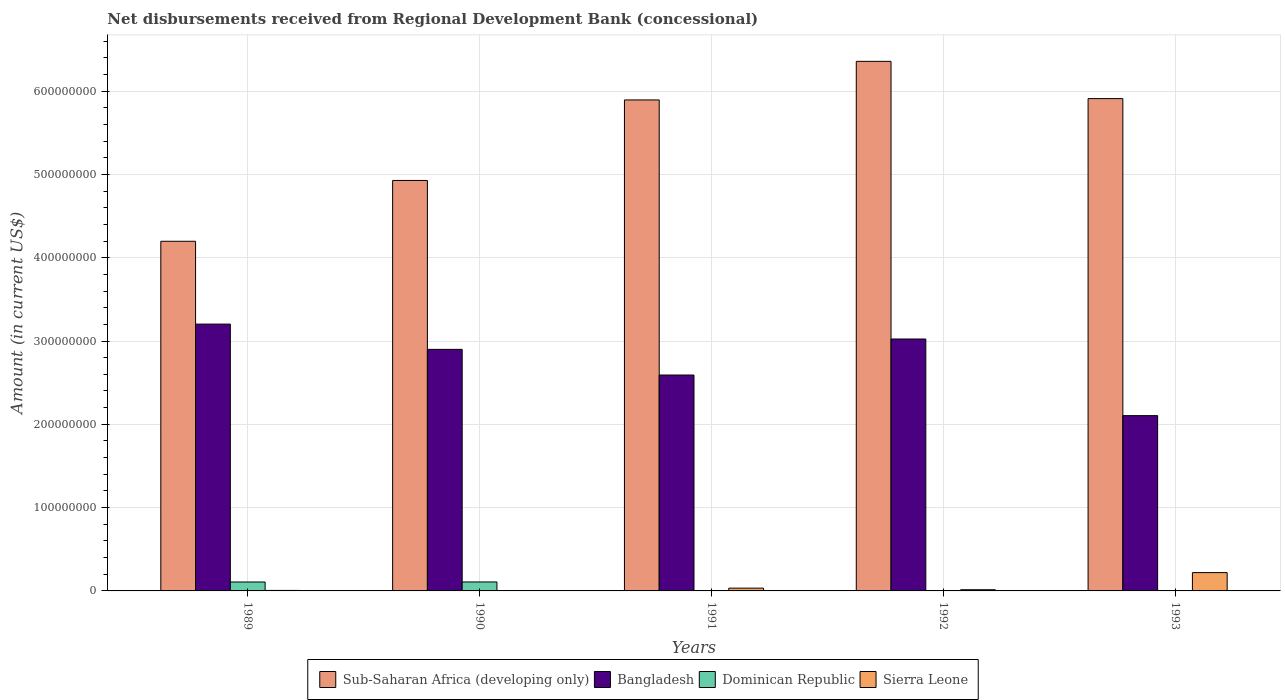How many groups of bars are there?
Keep it short and to the point. 5. Are the number of bars per tick equal to the number of legend labels?
Offer a very short reply. No. Are the number of bars on each tick of the X-axis equal?
Your answer should be very brief. No. How many bars are there on the 5th tick from the left?
Keep it short and to the point. 3. How many bars are there on the 4th tick from the right?
Provide a succinct answer. 3. What is the label of the 2nd group of bars from the left?
Provide a short and direct response. 1990. What is the amount of disbursements received from Regional Development Bank in Sierra Leone in 1991?
Your answer should be compact. 3.33e+06. Across all years, what is the maximum amount of disbursements received from Regional Development Bank in Bangladesh?
Give a very brief answer. 3.20e+08. Across all years, what is the minimum amount of disbursements received from Regional Development Bank in Sub-Saharan Africa (developing only)?
Offer a very short reply. 4.20e+08. In which year was the amount of disbursements received from Regional Development Bank in Dominican Republic maximum?
Keep it short and to the point. 1990. What is the total amount of disbursements received from Regional Development Bank in Sierra Leone in the graph?
Give a very brief answer. 2.73e+07. What is the difference between the amount of disbursements received from Regional Development Bank in Sub-Saharan Africa (developing only) in 1989 and that in 1992?
Your answer should be compact. -2.16e+08. What is the difference between the amount of disbursements received from Regional Development Bank in Dominican Republic in 1992 and the amount of disbursements received from Regional Development Bank in Bangladesh in 1991?
Your answer should be compact. -2.59e+08. What is the average amount of disbursements received from Regional Development Bank in Sierra Leone per year?
Keep it short and to the point. 5.47e+06. In the year 1992, what is the difference between the amount of disbursements received from Regional Development Bank in Bangladesh and amount of disbursements received from Regional Development Bank in Sierra Leone?
Ensure brevity in your answer.  3.01e+08. In how many years, is the amount of disbursements received from Regional Development Bank in Dominican Republic greater than 140000000 US$?
Keep it short and to the point. 0. What is the ratio of the amount of disbursements received from Regional Development Bank in Sierra Leone in 1991 to that in 1992?
Offer a terse response. 2.33. Is the difference between the amount of disbursements received from Regional Development Bank in Bangladesh in 1989 and 1992 greater than the difference between the amount of disbursements received from Regional Development Bank in Sierra Leone in 1989 and 1992?
Provide a short and direct response. Yes. What is the difference between the highest and the second highest amount of disbursements received from Regional Development Bank in Sub-Saharan Africa (developing only)?
Offer a terse response. 4.47e+07. What is the difference between the highest and the lowest amount of disbursements received from Regional Development Bank in Sierra Leone?
Offer a terse response. 2.20e+07. Is it the case that in every year, the sum of the amount of disbursements received from Regional Development Bank in Sierra Leone and amount of disbursements received from Regional Development Bank in Sub-Saharan Africa (developing only) is greater than the sum of amount of disbursements received from Regional Development Bank in Dominican Republic and amount of disbursements received from Regional Development Bank in Bangladesh?
Offer a very short reply. Yes. Are all the bars in the graph horizontal?
Offer a very short reply. No. What is the difference between two consecutive major ticks on the Y-axis?
Ensure brevity in your answer.  1.00e+08. Are the values on the major ticks of Y-axis written in scientific E-notation?
Your response must be concise. No. Does the graph contain any zero values?
Keep it short and to the point. Yes. Does the graph contain grids?
Offer a very short reply. Yes. How many legend labels are there?
Provide a succinct answer. 4. How are the legend labels stacked?
Give a very brief answer. Horizontal. What is the title of the graph?
Make the answer very short. Net disbursements received from Regional Development Bank (concessional). What is the Amount (in current US$) in Sub-Saharan Africa (developing only) in 1989?
Provide a short and direct response. 4.20e+08. What is the Amount (in current US$) of Bangladesh in 1989?
Keep it short and to the point. 3.20e+08. What is the Amount (in current US$) of Dominican Republic in 1989?
Offer a terse response. 1.07e+07. What is the Amount (in current US$) of Sierra Leone in 1989?
Your answer should be very brief. 6.03e+05. What is the Amount (in current US$) in Sub-Saharan Africa (developing only) in 1990?
Your response must be concise. 4.93e+08. What is the Amount (in current US$) of Bangladesh in 1990?
Make the answer very short. 2.90e+08. What is the Amount (in current US$) of Dominican Republic in 1990?
Provide a succinct answer. 1.08e+07. What is the Amount (in current US$) of Sub-Saharan Africa (developing only) in 1991?
Your response must be concise. 5.89e+08. What is the Amount (in current US$) of Bangladesh in 1991?
Ensure brevity in your answer.  2.59e+08. What is the Amount (in current US$) in Sierra Leone in 1991?
Your response must be concise. 3.33e+06. What is the Amount (in current US$) in Sub-Saharan Africa (developing only) in 1992?
Make the answer very short. 6.36e+08. What is the Amount (in current US$) in Bangladesh in 1992?
Make the answer very short. 3.02e+08. What is the Amount (in current US$) in Dominican Republic in 1992?
Give a very brief answer. 0. What is the Amount (in current US$) of Sierra Leone in 1992?
Provide a short and direct response. 1.43e+06. What is the Amount (in current US$) of Sub-Saharan Africa (developing only) in 1993?
Ensure brevity in your answer.  5.91e+08. What is the Amount (in current US$) of Bangladesh in 1993?
Your answer should be compact. 2.10e+08. What is the Amount (in current US$) in Sierra Leone in 1993?
Ensure brevity in your answer.  2.20e+07. Across all years, what is the maximum Amount (in current US$) in Sub-Saharan Africa (developing only)?
Provide a short and direct response. 6.36e+08. Across all years, what is the maximum Amount (in current US$) of Bangladesh?
Provide a succinct answer. 3.20e+08. Across all years, what is the maximum Amount (in current US$) in Dominican Republic?
Your answer should be compact. 1.08e+07. Across all years, what is the maximum Amount (in current US$) of Sierra Leone?
Provide a succinct answer. 2.20e+07. Across all years, what is the minimum Amount (in current US$) in Sub-Saharan Africa (developing only)?
Keep it short and to the point. 4.20e+08. Across all years, what is the minimum Amount (in current US$) of Bangladesh?
Give a very brief answer. 2.10e+08. Across all years, what is the minimum Amount (in current US$) in Dominican Republic?
Your answer should be very brief. 0. What is the total Amount (in current US$) of Sub-Saharan Africa (developing only) in the graph?
Ensure brevity in your answer.  2.73e+09. What is the total Amount (in current US$) of Bangladesh in the graph?
Keep it short and to the point. 1.38e+09. What is the total Amount (in current US$) of Dominican Republic in the graph?
Keep it short and to the point. 2.15e+07. What is the total Amount (in current US$) in Sierra Leone in the graph?
Offer a terse response. 2.73e+07. What is the difference between the Amount (in current US$) in Sub-Saharan Africa (developing only) in 1989 and that in 1990?
Give a very brief answer. -7.30e+07. What is the difference between the Amount (in current US$) in Bangladesh in 1989 and that in 1990?
Your answer should be compact. 3.03e+07. What is the difference between the Amount (in current US$) of Dominican Republic in 1989 and that in 1990?
Your answer should be very brief. -3.80e+04. What is the difference between the Amount (in current US$) in Sub-Saharan Africa (developing only) in 1989 and that in 1991?
Give a very brief answer. -1.70e+08. What is the difference between the Amount (in current US$) in Bangladesh in 1989 and that in 1991?
Give a very brief answer. 6.11e+07. What is the difference between the Amount (in current US$) of Sierra Leone in 1989 and that in 1991?
Your answer should be compact. -2.73e+06. What is the difference between the Amount (in current US$) of Sub-Saharan Africa (developing only) in 1989 and that in 1992?
Offer a terse response. -2.16e+08. What is the difference between the Amount (in current US$) in Bangladesh in 1989 and that in 1992?
Your answer should be compact. 1.79e+07. What is the difference between the Amount (in current US$) of Sierra Leone in 1989 and that in 1992?
Your answer should be very brief. -8.28e+05. What is the difference between the Amount (in current US$) in Sub-Saharan Africa (developing only) in 1989 and that in 1993?
Your response must be concise. -1.71e+08. What is the difference between the Amount (in current US$) in Bangladesh in 1989 and that in 1993?
Your answer should be compact. 1.10e+08. What is the difference between the Amount (in current US$) in Sierra Leone in 1989 and that in 1993?
Your answer should be compact. -2.14e+07. What is the difference between the Amount (in current US$) in Sub-Saharan Africa (developing only) in 1990 and that in 1991?
Offer a terse response. -9.66e+07. What is the difference between the Amount (in current US$) in Bangladesh in 1990 and that in 1991?
Provide a succinct answer. 3.08e+07. What is the difference between the Amount (in current US$) in Sub-Saharan Africa (developing only) in 1990 and that in 1992?
Keep it short and to the point. -1.43e+08. What is the difference between the Amount (in current US$) of Bangladesh in 1990 and that in 1992?
Offer a very short reply. -1.24e+07. What is the difference between the Amount (in current US$) of Sub-Saharan Africa (developing only) in 1990 and that in 1993?
Offer a very short reply. -9.82e+07. What is the difference between the Amount (in current US$) of Bangladesh in 1990 and that in 1993?
Offer a terse response. 7.95e+07. What is the difference between the Amount (in current US$) of Sub-Saharan Africa (developing only) in 1991 and that in 1992?
Give a very brief answer. -4.63e+07. What is the difference between the Amount (in current US$) in Bangladesh in 1991 and that in 1992?
Provide a short and direct response. -4.32e+07. What is the difference between the Amount (in current US$) of Sierra Leone in 1991 and that in 1992?
Offer a very short reply. 1.90e+06. What is the difference between the Amount (in current US$) of Sub-Saharan Africa (developing only) in 1991 and that in 1993?
Offer a very short reply. -1.59e+06. What is the difference between the Amount (in current US$) of Bangladesh in 1991 and that in 1993?
Your answer should be compact. 4.87e+07. What is the difference between the Amount (in current US$) in Sierra Leone in 1991 and that in 1993?
Provide a short and direct response. -1.87e+07. What is the difference between the Amount (in current US$) in Sub-Saharan Africa (developing only) in 1992 and that in 1993?
Your response must be concise. 4.47e+07. What is the difference between the Amount (in current US$) of Bangladesh in 1992 and that in 1993?
Provide a short and direct response. 9.20e+07. What is the difference between the Amount (in current US$) of Sierra Leone in 1992 and that in 1993?
Your answer should be very brief. -2.06e+07. What is the difference between the Amount (in current US$) in Sub-Saharan Africa (developing only) in 1989 and the Amount (in current US$) in Bangladesh in 1990?
Ensure brevity in your answer.  1.30e+08. What is the difference between the Amount (in current US$) of Sub-Saharan Africa (developing only) in 1989 and the Amount (in current US$) of Dominican Republic in 1990?
Provide a short and direct response. 4.09e+08. What is the difference between the Amount (in current US$) in Bangladesh in 1989 and the Amount (in current US$) in Dominican Republic in 1990?
Provide a succinct answer. 3.10e+08. What is the difference between the Amount (in current US$) in Sub-Saharan Africa (developing only) in 1989 and the Amount (in current US$) in Bangladesh in 1991?
Give a very brief answer. 1.61e+08. What is the difference between the Amount (in current US$) in Sub-Saharan Africa (developing only) in 1989 and the Amount (in current US$) in Sierra Leone in 1991?
Make the answer very short. 4.16e+08. What is the difference between the Amount (in current US$) in Bangladesh in 1989 and the Amount (in current US$) in Sierra Leone in 1991?
Offer a very short reply. 3.17e+08. What is the difference between the Amount (in current US$) of Dominican Republic in 1989 and the Amount (in current US$) of Sierra Leone in 1991?
Offer a very short reply. 7.40e+06. What is the difference between the Amount (in current US$) in Sub-Saharan Africa (developing only) in 1989 and the Amount (in current US$) in Bangladesh in 1992?
Keep it short and to the point. 1.17e+08. What is the difference between the Amount (in current US$) of Sub-Saharan Africa (developing only) in 1989 and the Amount (in current US$) of Sierra Leone in 1992?
Offer a very short reply. 4.18e+08. What is the difference between the Amount (in current US$) of Bangladesh in 1989 and the Amount (in current US$) of Sierra Leone in 1992?
Keep it short and to the point. 3.19e+08. What is the difference between the Amount (in current US$) in Dominican Republic in 1989 and the Amount (in current US$) in Sierra Leone in 1992?
Offer a terse response. 9.30e+06. What is the difference between the Amount (in current US$) of Sub-Saharan Africa (developing only) in 1989 and the Amount (in current US$) of Bangladesh in 1993?
Your answer should be compact. 2.09e+08. What is the difference between the Amount (in current US$) in Sub-Saharan Africa (developing only) in 1989 and the Amount (in current US$) in Sierra Leone in 1993?
Your response must be concise. 3.98e+08. What is the difference between the Amount (in current US$) in Bangladesh in 1989 and the Amount (in current US$) in Sierra Leone in 1993?
Your answer should be very brief. 2.98e+08. What is the difference between the Amount (in current US$) of Dominican Republic in 1989 and the Amount (in current US$) of Sierra Leone in 1993?
Offer a very short reply. -1.13e+07. What is the difference between the Amount (in current US$) of Sub-Saharan Africa (developing only) in 1990 and the Amount (in current US$) of Bangladesh in 1991?
Offer a very short reply. 2.34e+08. What is the difference between the Amount (in current US$) of Sub-Saharan Africa (developing only) in 1990 and the Amount (in current US$) of Sierra Leone in 1991?
Provide a succinct answer. 4.89e+08. What is the difference between the Amount (in current US$) in Bangladesh in 1990 and the Amount (in current US$) in Sierra Leone in 1991?
Provide a short and direct response. 2.87e+08. What is the difference between the Amount (in current US$) in Dominican Republic in 1990 and the Amount (in current US$) in Sierra Leone in 1991?
Provide a succinct answer. 7.44e+06. What is the difference between the Amount (in current US$) in Sub-Saharan Africa (developing only) in 1990 and the Amount (in current US$) in Bangladesh in 1992?
Make the answer very short. 1.90e+08. What is the difference between the Amount (in current US$) in Sub-Saharan Africa (developing only) in 1990 and the Amount (in current US$) in Sierra Leone in 1992?
Provide a short and direct response. 4.91e+08. What is the difference between the Amount (in current US$) of Bangladesh in 1990 and the Amount (in current US$) of Sierra Leone in 1992?
Provide a succinct answer. 2.89e+08. What is the difference between the Amount (in current US$) in Dominican Republic in 1990 and the Amount (in current US$) in Sierra Leone in 1992?
Provide a short and direct response. 9.33e+06. What is the difference between the Amount (in current US$) in Sub-Saharan Africa (developing only) in 1990 and the Amount (in current US$) in Bangladesh in 1993?
Give a very brief answer. 2.82e+08. What is the difference between the Amount (in current US$) in Sub-Saharan Africa (developing only) in 1990 and the Amount (in current US$) in Sierra Leone in 1993?
Offer a terse response. 4.71e+08. What is the difference between the Amount (in current US$) of Bangladesh in 1990 and the Amount (in current US$) of Sierra Leone in 1993?
Offer a very short reply. 2.68e+08. What is the difference between the Amount (in current US$) in Dominican Republic in 1990 and the Amount (in current US$) in Sierra Leone in 1993?
Provide a succinct answer. -1.12e+07. What is the difference between the Amount (in current US$) in Sub-Saharan Africa (developing only) in 1991 and the Amount (in current US$) in Bangladesh in 1992?
Your response must be concise. 2.87e+08. What is the difference between the Amount (in current US$) in Sub-Saharan Africa (developing only) in 1991 and the Amount (in current US$) in Sierra Leone in 1992?
Keep it short and to the point. 5.88e+08. What is the difference between the Amount (in current US$) of Bangladesh in 1991 and the Amount (in current US$) of Sierra Leone in 1992?
Give a very brief answer. 2.58e+08. What is the difference between the Amount (in current US$) in Sub-Saharan Africa (developing only) in 1991 and the Amount (in current US$) in Bangladesh in 1993?
Your response must be concise. 3.79e+08. What is the difference between the Amount (in current US$) of Sub-Saharan Africa (developing only) in 1991 and the Amount (in current US$) of Sierra Leone in 1993?
Keep it short and to the point. 5.67e+08. What is the difference between the Amount (in current US$) in Bangladesh in 1991 and the Amount (in current US$) in Sierra Leone in 1993?
Your answer should be compact. 2.37e+08. What is the difference between the Amount (in current US$) in Sub-Saharan Africa (developing only) in 1992 and the Amount (in current US$) in Bangladesh in 1993?
Provide a short and direct response. 4.25e+08. What is the difference between the Amount (in current US$) of Sub-Saharan Africa (developing only) in 1992 and the Amount (in current US$) of Sierra Leone in 1993?
Ensure brevity in your answer.  6.14e+08. What is the difference between the Amount (in current US$) of Bangladesh in 1992 and the Amount (in current US$) of Sierra Leone in 1993?
Keep it short and to the point. 2.80e+08. What is the average Amount (in current US$) of Sub-Saharan Africa (developing only) per year?
Make the answer very short. 5.46e+08. What is the average Amount (in current US$) in Bangladesh per year?
Offer a terse response. 2.76e+08. What is the average Amount (in current US$) in Dominican Republic per year?
Provide a short and direct response. 4.30e+06. What is the average Amount (in current US$) in Sierra Leone per year?
Ensure brevity in your answer.  5.47e+06. In the year 1989, what is the difference between the Amount (in current US$) of Sub-Saharan Africa (developing only) and Amount (in current US$) of Bangladesh?
Offer a terse response. 9.94e+07. In the year 1989, what is the difference between the Amount (in current US$) in Sub-Saharan Africa (developing only) and Amount (in current US$) in Dominican Republic?
Your answer should be very brief. 4.09e+08. In the year 1989, what is the difference between the Amount (in current US$) of Sub-Saharan Africa (developing only) and Amount (in current US$) of Sierra Leone?
Give a very brief answer. 4.19e+08. In the year 1989, what is the difference between the Amount (in current US$) of Bangladesh and Amount (in current US$) of Dominican Republic?
Provide a short and direct response. 3.10e+08. In the year 1989, what is the difference between the Amount (in current US$) in Bangladesh and Amount (in current US$) in Sierra Leone?
Your answer should be very brief. 3.20e+08. In the year 1989, what is the difference between the Amount (in current US$) in Dominican Republic and Amount (in current US$) in Sierra Leone?
Offer a terse response. 1.01e+07. In the year 1990, what is the difference between the Amount (in current US$) of Sub-Saharan Africa (developing only) and Amount (in current US$) of Bangladesh?
Offer a terse response. 2.03e+08. In the year 1990, what is the difference between the Amount (in current US$) of Sub-Saharan Africa (developing only) and Amount (in current US$) of Dominican Republic?
Provide a short and direct response. 4.82e+08. In the year 1990, what is the difference between the Amount (in current US$) of Bangladesh and Amount (in current US$) of Dominican Republic?
Provide a succinct answer. 2.79e+08. In the year 1991, what is the difference between the Amount (in current US$) of Sub-Saharan Africa (developing only) and Amount (in current US$) of Bangladesh?
Give a very brief answer. 3.30e+08. In the year 1991, what is the difference between the Amount (in current US$) in Sub-Saharan Africa (developing only) and Amount (in current US$) in Sierra Leone?
Your answer should be compact. 5.86e+08. In the year 1991, what is the difference between the Amount (in current US$) of Bangladesh and Amount (in current US$) of Sierra Leone?
Give a very brief answer. 2.56e+08. In the year 1992, what is the difference between the Amount (in current US$) in Sub-Saharan Africa (developing only) and Amount (in current US$) in Bangladesh?
Your response must be concise. 3.33e+08. In the year 1992, what is the difference between the Amount (in current US$) in Sub-Saharan Africa (developing only) and Amount (in current US$) in Sierra Leone?
Provide a succinct answer. 6.34e+08. In the year 1992, what is the difference between the Amount (in current US$) of Bangladesh and Amount (in current US$) of Sierra Leone?
Your response must be concise. 3.01e+08. In the year 1993, what is the difference between the Amount (in current US$) in Sub-Saharan Africa (developing only) and Amount (in current US$) in Bangladesh?
Provide a succinct answer. 3.81e+08. In the year 1993, what is the difference between the Amount (in current US$) of Sub-Saharan Africa (developing only) and Amount (in current US$) of Sierra Leone?
Make the answer very short. 5.69e+08. In the year 1993, what is the difference between the Amount (in current US$) of Bangladesh and Amount (in current US$) of Sierra Leone?
Give a very brief answer. 1.88e+08. What is the ratio of the Amount (in current US$) in Sub-Saharan Africa (developing only) in 1989 to that in 1990?
Make the answer very short. 0.85. What is the ratio of the Amount (in current US$) of Bangladesh in 1989 to that in 1990?
Offer a very short reply. 1.1. What is the ratio of the Amount (in current US$) of Sub-Saharan Africa (developing only) in 1989 to that in 1991?
Provide a succinct answer. 0.71. What is the ratio of the Amount (in current US$) in Bangladesh in 1989 to that in 1991?
Your answer should be compact. 1.24. What is the ratio of the Amount (in current US$) in Sierra Leone in 1989 to that in 1991?
Your answer should be very brief. 0.18. What is the ratio of the Amount (in current US$) in Sub-Saharan Africa (developing only) in 1989 to that in 1992?
Offer a terse response. 0.66. What is the ratio of the Amount (in current US$) of Bangladesh in 1989 to that in 1992?
Offer a very short reply. 1.06. What is the ratio of the Amount (in current US$) of Sierra Leone in 1989 to that in 1992?
Your response must be concise. 0.42. What is the ratio of the Amount (in current US$) of Sub-Saharan Africa (developing only) in 1989 to that in 1993?
Provide a succinct answer. 0.71. What is the ratio of the Amount (in current US$) in Bangladesh in 1989 to that in 1993?
Your response must be concise. 1.52. What is the ratio of the Amount (in current US$) of Sierra Leone in 1989 to that in 1993?
Give a very brief answer. 0.03. What is the ratio of the Amount (in current US$) in Sub-Saharan Africa (developing only) in 1990 to that in 1991?
Ensure brevity in your answer.  0.84. What is the ratio of the Amount (in current US$) in Bangladesh in 1990 to that in 1991?
Keep it short and to the point. 1.12. What is the ratio of the Amount (in current US$) in Sub-Saharan Africa (developing only) in 1990 to that in 1992?
Your answer should be very brief. 0.78. What is the ratio of the Amount (in current US$) of Bangladesh in 1990 to that in 1992?
Your answer should be very brief. 0.96. What is the ratio of the Amount (in current US$) in Sub-Saharan Africa (developing only) in 1990 to that in 1993?
Ensure brevity in your answer.  0.83. What is the ratio of the Amount (in current US$) in Bangladesh in 1990 to that in 1993?
Keep it short and to the point. 1.38. What is the ratio of the Amount (in current US$) in Sub-Saharan Africa (developing only) in 1991 to that in 1992?
Make the answer very short. 0.93. What is the ratio of the Amount (in current US$) in Bangladesh in 1991 to that in 1992?
Keep it short and to the point. 0.86. What is the ratio of the Amount (in current US$) in Sierra Leone in 1991 to that in 1992?
Make the answer very short. 2.33. What is the ratio of the Amount (in current US$) in Sub-Saharan Africa (developing only) in 1991 to that in 1993?
Keep it short and to the point. 1. What is the ratio of the Amount (in current US$) of Bangladesh in 1991 to that in 1993?
Give a very brief answer. 1.23. What is the ratio of the Amount (in current US$) in Sierra Leone in 1991 to that in 1993?
Offer a very short reply. 0.15. What is the ratio of the Amount (in current US$) of Sub-Saharan Africa (developing only) in 1992 to that in 1993?
Make the answer very short. 1.08. What is the ratio of the Amount (in current US$) in Bangladesh in 1992 to that in 1993?
Your response must be concise. 1.44. What is the ratio of the Amount (in current US$) of Sierra Leone in 1992 to that in 1993?
Keep it short and to the point. 0.07. What is the difference between the highest and the second highest Amount (in current US$) in Sub-Saharan Africa (developing only)?
Offer a very short reply. 4.47e+07. What is the difference between the highest and the second highest Amount (in current US$) of Bangladesh?
Offer a terse response. 1.79e+07. What is the difference between the highest and the second highest Amount (in current US$) of Sierra Leone?
Give a very brief answer. 1.87e+07. What is the difference between the highest and the lowest Amount (in current US$) of Sub-Saharan Africa (developing only)?
Ensure brevity in your answer.  2.16e+08. What is the difference between the highest and the lowest Amount (in current US$) of Bangladesh?
Make the answer very short. 1.10e+08. What is the difference between the highest and the lowest Amount (in current US$) of Dominican Republic?
Provide a succinct answer. 1.08e+07. What is the difference between the highest and the lowest Amount (in current US$) of Sierra Leone?
Keep it short and to the point. 2.20e+07. 